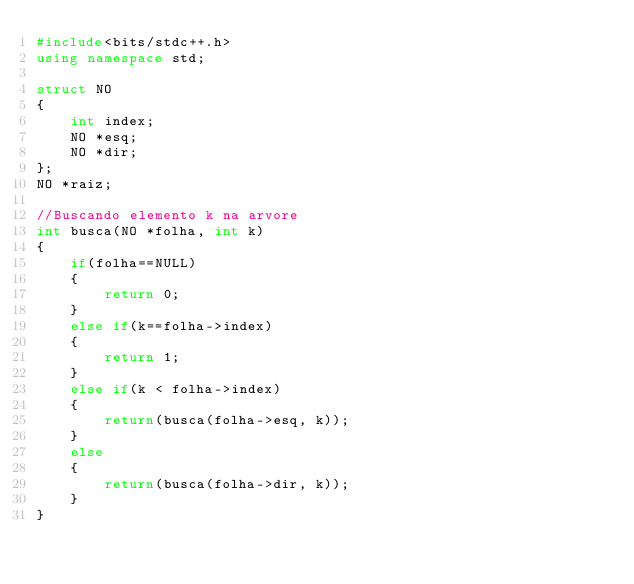<code> <loc_0><loc_0><loc_500><loc_500><_C++_>#include<bits/stdc++.h>
using namespace std;

struct NO
{
    int index;
    NO *esq;
    NO *dir;
};
NO *raiz;

//Buscando elemento k na arvore
int busca(NO *folha, int k)
{
    if(folha==NULL)
    {
        return 0;
    }
    else if(k==folha->index)
    {
        return 1;
    }
    else if(k < folha->index)
    {
        return(busca(folha->esq, k));
    }
    else
    {
        return(busca(folha->dir, k));
    }
}</code> 